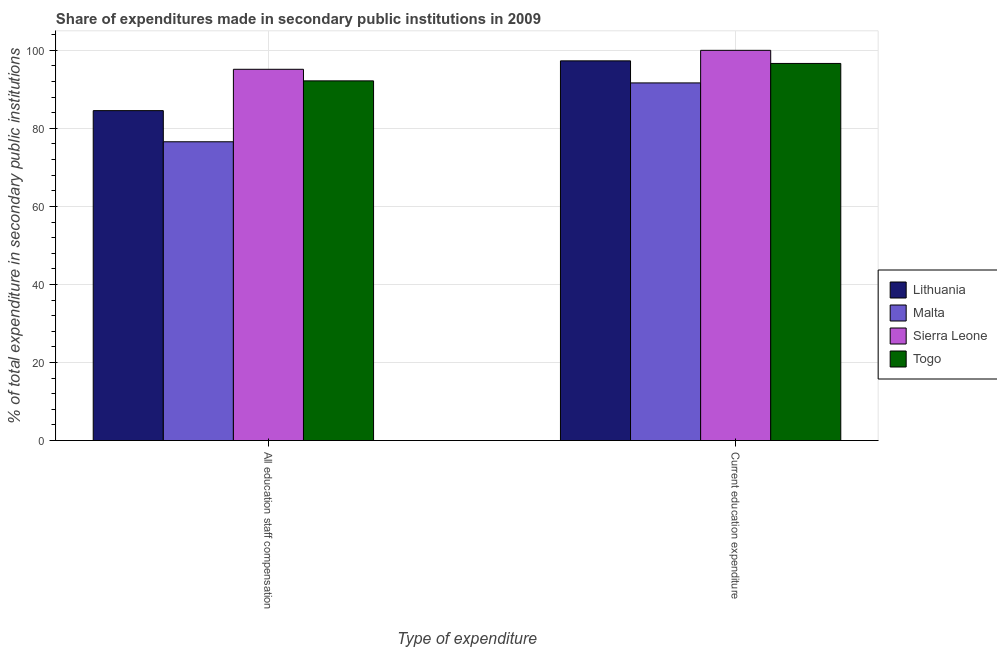Are the number of bars per tick equal to the number of legend labels?
Ensure brevity in your answer.  Yes. What is the label of the 1st group of bars from the left?
Make the answer very short. All education staff compensation. What is the expenditure in staff compensation in Lithuania?
Your response must be concise. 84.55. Across all countries, what is the minimum expenditure in staff compensation?
Your response must be concise. 76.57. In which country was the expenditure in education maximum?
Your answer should be very brief. Sierra Leone. In which country was the expenditure in education minimum?
Your answer should be compact. Malta. What is the total expenditure in education in the graph?
Offer a very short reply. 385.6. What is the difference between the expenditure in education in Malta and that in Lithuania?
Make the answer very short. -5.65. What is the difference between the expenditure in education in Sierra Leone and the expenditure in staff compensation in Togo?
Your response must be concise. 7.82. What is the average expenditure in staff compensation per country?
Your answer should be compact. 87.11. What is the difference between the expenditure in staff compensation and expenditure in education in Togo?
Give a very brief answer. -4.46. What is the ratio of the expenditure in education in Lithuania to that in Malta?
Ensure brevity in your answer.  1.06. In how many countries, is the expenditure in education greater than the average expenditure in education taken over all countries?
Your answer should be very brief. 3. What does the 3rd bar from the left in Current education expenditure represents?
Keep it short and to the point. Sierra Leone. What does the 2nd bar from the right in All education staff compensation represents?
Offer a very short reply. Sierra Leone. Are all the bars in the graph horizontal?
Provide a short and direct response. No. How many countries are there in the graph?
Your answer should be very brief. 4. Are the values on the major ticks of Y-axis written in scientific E-notation?
Provide a short and direct response. No. Does the graph contain any zero values?
Make the answer very short. No. How are the legend labels stacked?
Your response must be concise. Vertical. What is the title of the graph?
Provide a succinct answer. Share of expenditures made in secondary public institutions in 2009. What is the label or title of the X-axis?
Your response must be concise. Type of expenditure. What is the label or title of the Y-axis?
Your answer should be very brief. % of total expenditure in secondary public institutions. What is the % of total expenditure in secondary public institutions of Lithuania in All education staff compensation?
Your response must be concise. 84.55. What is the % of total expenditure in secondary public institutions in Malta in All education staff compensation?
Provide a succinct answer. 76.57. What is the % of total expenditure in secondary public institutions in Sierra Leone in All education staff compensation?
Offer a very short reply. 95.14. What is the % of total expenditure in secondary public institutions in Togo in All education staff compensation?
Make the answer very short. 92.18. What is the % of total expenditure in secondary public institutions in Lithuania in Current education expenditure?
Provide a short and direct response. 97.3. What is the % of total expenditure in secondary public institutions of Malta in Current education expenditure?
Provide a succinct answer. 91.65. What is the % of total expenditure in secondary public institutions of Togo in Current education expenditure?
Your answer should be very brief. 96.64. Across all Type of expenditure, what is the maximum % of total expenditure in secondary public institutions in Lithuania?
Offer a terse response. 97.3. Across all Type of expenditure, what is the maximum % of total expenditure in secondary public institutions in Malta?
Provide a short and direct response. 91.65. Across all Type of expenditure, what is the maximum % of total expenditure in secondary public institutions in Sierra Leone?
Provide a succinct answer. 100. Across all Type of expenditure, what is the maximum % of total expenditure in secondary public institutions of Togo?
Make the answer very short. 96.64. Across all Type of expenditure, what is the minimum % of total expenditure in secondary public institutions of Lithuania?
Keep it short and to the point. 84.55. Across all Type of expenditure, what is the minimum % of total expenditure in secondary public institutions in Malta?
Provide a succinct answer. 76.57. Across all Type of expenditure, what is the minimum % of total expenditure in secondary public institutions in Sierra Leone?
Offer a very short reply. 95.14. Across all Type of expenditure, what is the minimum % of total expenditure in secondary public institutions in Togo?
Your answer should be compact. 92.18. What is the total % of total expenditure in secondary public institutions in Lithuania in the graph?
Make the answer very short. 181.85. What is the total % of total expenditure in secondary public institutions of Malta in the graph?
Your answer should be compact. 168.22. What is the total % of total expenditure in secondary public institutions in Sierra Leone in the graph?
Your response must be concise. 195.14. What is the total % of total expenditure in secondary public institutions in Togo in the graph?
Make the answer very short. 188.82. What is the difference between the % of total expenditure in secondary public institutions of Lithuania in All education staff compensation and that in Current education expenditure?
Your answer should be compact. -12.75. What is the difference between the % of total expenditure in secondary public institutions in Malta in All education staff compensation and that in Current education expenditure?
Keep it short and to the point. -15.08. What is the difference between the % of total expenditure in secondary public institutions in Sierra Leone in All education staff compensation and that in Current education expenditure?
Offer a terse response. -4.86. What is the difference between the % of total expenditure in secondary public institutions in Togo in All education staff compensation and that in Current education expenditure?
Keep it short and to the point. -4.46. What is the difference between the % of total expenditure in secondary public institutions of Lithuania in All education staff compensation and the % of total expenditure in secondary public institutions of Malta in Current education expenditure?
Provide a succinct answer. -7.1. What is the difference between the % of total expenditure in secondary public institutions of Lithuania in All education staff compensation and the % of total expenditure in secondary public institutions of Sierra Leone in Current education expenditure?
Offer a terse response. -15.45. What is the difference between the % of total expenditure in secondary public institutions of Lithuania in All education staff compensation and the % of total expenditure in secondary public institutions of Togo in Current education expenditure?
Ensure brevity in your answer.  -12.09. What is the difference between the % of total expenditure in secondary public institutions in Malta in All education staff compensation and the % of total expenditure in secondary public institutions in Sierra Leone in Current education expenditure?
Keep it short and to the point. -23.43. What is the difference between the % of total expenditure in secondary public institutions of Malta in All education staff compensation and the % of total expenditure in secondary public institutions of Togo in Current education expenditure?
Keep it short and to the point. -20.07. What is the difference between the % of total expenditure in secondary public institutions of Sierra Leone in All education staff compensation and the % of total expenditure in secondary public institutions of Togo in Current education expenditure?
Offer a terse response. -1.5. What is the average % of total expenditure in secondary public institutions in Lithuania per Type of expenditure?
Your answer should be compact. 90.93. What is the average % of total expenditure in secondary public institutions in Malta per Type of expenditure?
Offer a very short reply. 84.11. What is the average % of total expenditure in secondary public institutions in Sierra Leone per Type of expenditure?
Your answer should be very brief. 97.57. What is the average % of total expenditure in secondary public institutions in Togo per Type of expenditure?
Keep it short and to the point. 94.41. What is the difference between the % of total expenditure in secondary public institutions of Lithuania and % of total expenditure in secondary public institutions of Malta in All education staff compensation?
Your response must be concise. 7.98. What is the difference between the % of total expenditure in secondary public institutions in Lithuania and % of total expenditure in secondary public institutions in Sierra Leone in All education staff compensation?
Your answer should be very brief. -10.59. What is the difference between the % of total expenditure in secondary public institutions of Lithuania and % of total expenditure in secondary public institutions of Togo in All education staff compensation?
Provide a short and direct response. -7.63. What is the difference between the % of total expenditure in secondary public institutions of Malta and % of total expenditure in secondary public institutions of Sierra Leone in All education staff compensation?
Your answer should be very brief. -18.57. What is the difference between the % of total expenditure in secondary public institutions in Malta and % of total expenditure in secondary public institutions in Togo in All education staff compensation?
Offer a very short reply. -15.61. What is the difference between the % of total expenditure in secondary public institutions in Sierra Leone and % of total expenditure in secondary public institutions in Togo in All education staff compensation?
Offer a very short reply. 2.97. What is the difference between the % of total expenditure in secondary public institutions in Lithuania and % of total expenditure in secondary public institutions in Malta in Current education expenditure?
Give a very brief answer. 5.65. What is the difference between the % of total expenditure in secondary public institutions of Lithuania and % of total expenditure in secondary public institutions of Sierra Leone in Current education expenditure?
Provide a succinct answer. -2.7. What is the difference between the % of total expenditure in secondary public institutions of Lithuania and % of total expenditure in secondary public institutions of Togo in Current education expenditure?
Your answer should be compact. 0.66. What is the difference between the % of total expenditure in secondary public institutions of Malta and % of total expenditure in secondary public institutions of Sierra Leone in Current education expenditure?
Make the answer very short. -8.35. What is the difference between the % of total expenditure in secondary public institutions in Malta and % of total expenditure in secondary public institutions in Togo in Current education expenditure?
Your response must be concise. -4.99. What is the difference between the % of total expenditure in secondary public institutions in Sierra Leone and % of total expenditure in secondary public institutions in Togo in Current education expenditure?
Provide a succinct answer. 3.36. What is the ratio of the % of total expenditure in secondary public institutions in Lithuania in All education staff compensation to that in Current education expenditure?
Provide a succinct answer. 0.87. What is the ratio of the % of total expenditure in secondary public institutions in Malta in All education staff compensation to that in Current education expenditure?
Offer a very short reply. 0.84. What is the ratio of the % of total expenditure in secondary public institutions in Sierra Leone in All education staff compensation to that in Current education expenditure?
Your answer should be compact. 0.95. What is the ratio of the % of total expenditure in secondary public institutions of Togo in All education staff compensation to that in Current education expenditure?
Provide a short and direct response. 0.95. What is the difference between the highest and the second highest % of total expenditure in secondary public institutions in Lithuania?
Give a very brief answer. 12.75. What is the difference between the highest and the second highest % of total expenditure in secondary public institutions in Malta?
Your answer should be compact. 15.08. What is the difference between the highest and the second highest % of total expenditure in secondary public institutions of Sierra Leone?
Your answer should be very brief. 4.86. What is the difference between the highest and the second highest % of total expenditure in secondary public institutions of Togo?
Provide a short and direct response. 4.46. What is the difference between the highest and the lowest % of total expenditure in secondary public institutions in Lithuania?
Provide a short and direct response. 12.75. What is the difference between the highest and the lowest % of total expenditure in secondary public institutions of Malta?
Give a very brief answer. 15.08. What is the difference between the highest and the lowest % of total expenditure in secondary public institutions in Sierra Leone?
Ensure brevity in your answer.  4.86. What is the difference between the highest and the lowest % of total expenditure in secondary public institutions of Togo?
Your answer should be very brief. 4.46. 